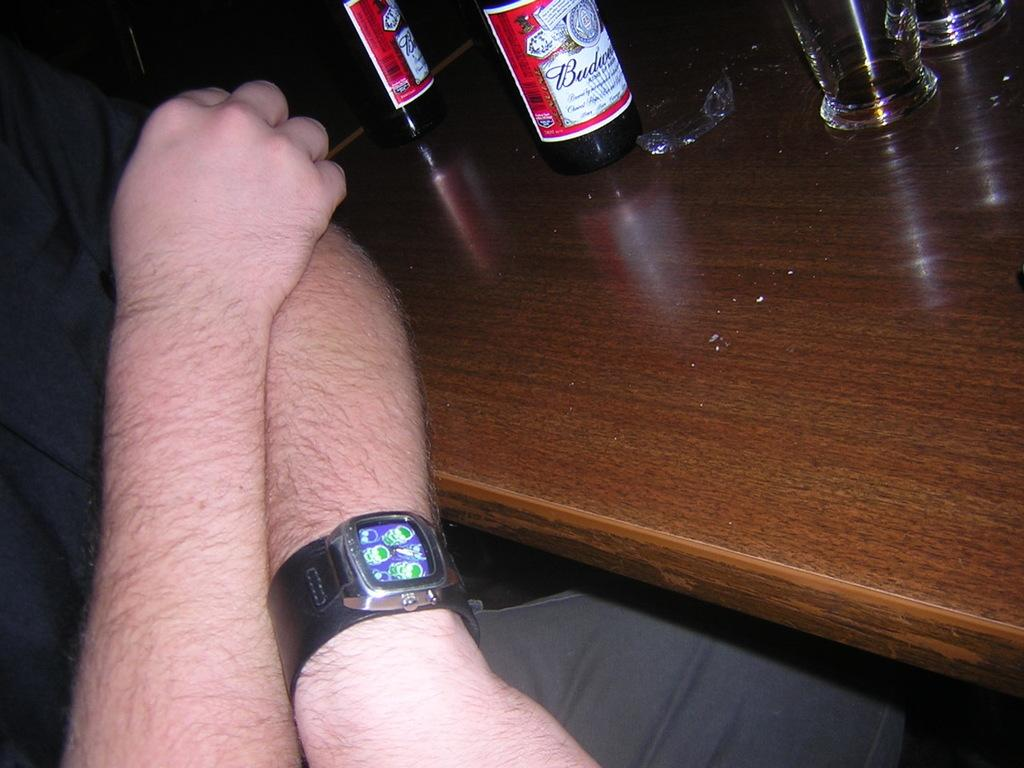<image>
Give a short and clear explanation of the subsequent image. Two bottles of Budweiser are on top of a bar. 